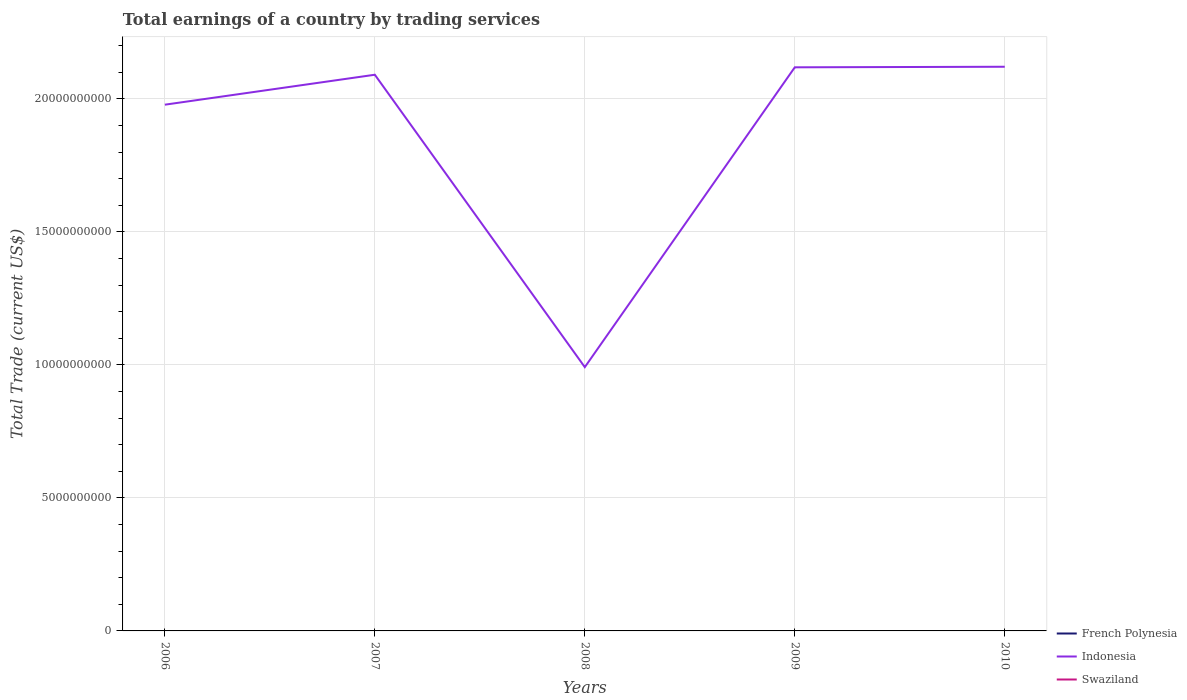Does the line corresponding to Swaziland intersect with the line corresponding to Indonesia?
Give a very brief answer. No. Is the number of lines equal to the number of legend labels?
Offer a very short reply. No. Across all years, what is the maximum total earnings in Indonesia?
Offer a terse response. 9.92e+09. What is the total total earnings in Indonesia in the graph?
Give a very brief answer. -1.13e+1. What is the difference between the highest and the second highest total earnings in Indonesia?
Keep it short and to the point. 1.13e+1. Is the total earnings in Swaziland strictly greater than the total earnings in French Polynesia over the years?
Your response must be concise. No. What is the difference between two consecutive major ticks on the Y-axis?
Your answer should be very brief. 5.00e+09. Are the values on the major ticks of Y-axis written in scientific E-notation?
Your answer should be very brief. No. Does the graph contain any zero values?
Provide a short and direct response. Yes. Does the graph contain grids?
Make the answer very short. Yes. Where does the legend appear in the graph?
Give a very brief answer. Bottom right. How many legend labels are there?
Keep it short and to the point. 3. What is the title of the graph?
Keep it short and to the point. Total earnings of a country by trading services. What is the label or title of the Y-axis?
Offer a terse response. Total Trade (current US$). What is the Total Trade (current US$) in French Polynesia in 2006?
Make the answer very short. 0. What is the Total Trade (current US$) of Indonesia in 2006?
Ensure brevity in your answer.  1.98e+1. What is the Total Trade (current US$) of Swaziland in 2006?
Your answer should be compact. 0. What is the Total Trade (current US$) in French Polynesia in 2007?
Provide a succinct answer. 0. What is the Total Trade (current US$) in Indonesia in 2007?
Give a very brief answer. 2.09e+1. What is the Total Trade (current US$) in French Polynesia in 2008?
Provide a succinct answer. 0. What is the Total Trade (current US$) of Indonesia in 2008?
Offer a terse response. 9.92e+09. What is the Total Trade (current US$) in Swaziland in 2008?
Your response must be concise. 0. What is the Total Trade (current US$) in Indonesia in 2009?
Your response must be concise. 2.12e+1. What is the Total Trade (current US$) of Swaziland in 2009?
Your answer should be compact. 0. What is the Total Trade (current US$) in French Polynesia in 2010?
Provide a short and direct response. 0. What is the Total Trade (current US$) in Indonesia in 2010?
Your answer should be very brief. 2.12e+1. What is the Total Trade (current US$) in Swaziland in 2010?
Your answer should be very brief. 0. Across all years, what is the maximum Total Trade (current US$) of Indonesia?
Your answer should be very brief. 2.12e+1. Across all years, what is the minimum Total Trade (current US$) of Indonesia?
Offer a very short reply. 9.92e+09. What is the total Total Trade (current US$) in Indonesia in the graph?
Provide a succinct answer. 9.30e+1. What is the difference between the Total Trade (current US$) of Indonesia in 2006 and that in 2007?
Ensure brevity in your answer.  -1.13e+09. What is the difference between the Total Trade (current US$) of Indonesia in 2006 and that in 2008?
Make the answer very short. 9.87e+09. What is the difference between the Total Trade (current US$) in Indonesia in 2006 and that in 2009?
Provide a succinct answer. -1.41e+09. What is the difference between the Total Trade (current US$) of Indonesia in 2006 and that in 2010?
Make the answer very short. -1.43e+09. What is the difference between the Total Trade (current US$) of Indonesia in 2007 and that in 2008?
Offer a very short reply. 1.10e+1. What is the difference between the Total Trade (current US$) in Indonesia in 2007 and that in 2009?
Provide a short and direct response. -2.79e+08. What is the difference between the Total Trade (current US$) of Indonesia in 2007 and that in 2010?
Your answer should be very brief. -3.00e+08. What is the difference between the Total Trade (current US$) of Indonesia in 2008 and that in 2009?
Offer a very short reply. -1.13e+1. What is the difference between the Total Trade (current US$) in Indonesia in 2008 and that in 2010?
Make the answer very short. -1.13e+1. What is the difference between the Total Trade (current US$) of Indonesia in 2009 and that in 2010?
Your answer should be very brief. -2.11e+07. What is the average Total Trade (current US$) in French Polynesia per year?
Your answer should be very brief. 0. What is the average Total Trade (current US$) in Indonesia per year?
Offer a terse response. 1.86e+1. What is the average Total Trade (current US$) in Swaziland per year?
Provide a succinct answer. 0. What is the ratio of the Total Trade (current US$) in Indonesia in 2006 to that in 2007?
Your answer should be very brief. 0.95. What is the ratio of the Total Trade (current US$) in Indonesia in 2006 to that in 2008?
Offer a very short reply. 2. What is the ratio of the Total Trade (current US$) of Indonesia in 2006 to that in 2009?
Your response must be concise. 0.93. What is the ratio of the Total Trade (current US$) in Indonesia in 2006 to that in 2010?
Your answer should be very brief. 0.93. What is the ratio of the Total Trade (current US$) of Indonesia in 2007 to that in 2008?
Your response must be concise. 2.11. What is the ratio of the Total Trade (current US$) of Indonesia in 2007 to that in 2010?
Offer a terse response. 0.99. What is the ratio of the Total Trade (current US$) of Indonesia in 2008 to that in 2009?
Keep it short and to the point. 0.47. What is the ratio of the Total Trade (current US$) of Indonesia in 2008 to that in 2010?
Provide a short and direct response. 0.47. What is the difference between the highest and the second highest Total Trade (current US$) of Indonesia?
Make the answer very short. 2.11e+07. What is the difference between the highest and the lowest Total Trade (current US$) of Indonesia?
Make the answer very short. 1.13e+1. 